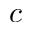Convert formula to latex. <formula><loc_0><loc_0><loc_500><loc_500>c</formula> 